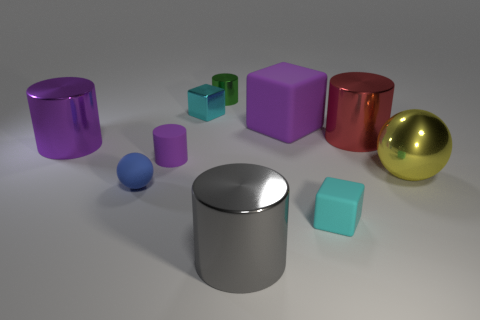Do the small object right of the small green metal cylinder and the large gray metal object have the same shape?
Keep it short and to the point. No. Is there a purple block?
Give a very brief answer. Yes. Is there any other thing that is the same shape as the yellow object?
Your response must be concise. Yes. Are there more small cyan metal objects that are right of the yellow ball than big purple metallic things?
Offer a terse response. No. There is a large yellow metal object; are there any tiny purple things in front of it?
Your answer should be very brief. No. Is the size of the blue object the same as the green thing?
Offer a very short reply. Yes. There is another object that is the same shape as the yellow thing; what is its size?
Ensure brevity in your answer.  Small. There is a big cylinder right of the large object in front of the small blue rubber sphere; what is its material?
Offer a terse response. Metal. Is the large purple shiny thing the same shape as the red shiny object?
Offer a terse response. Yes. How many small cyan things are both in front of the small matte cylinder and behind the red object?
Offer a terse response. 0. 